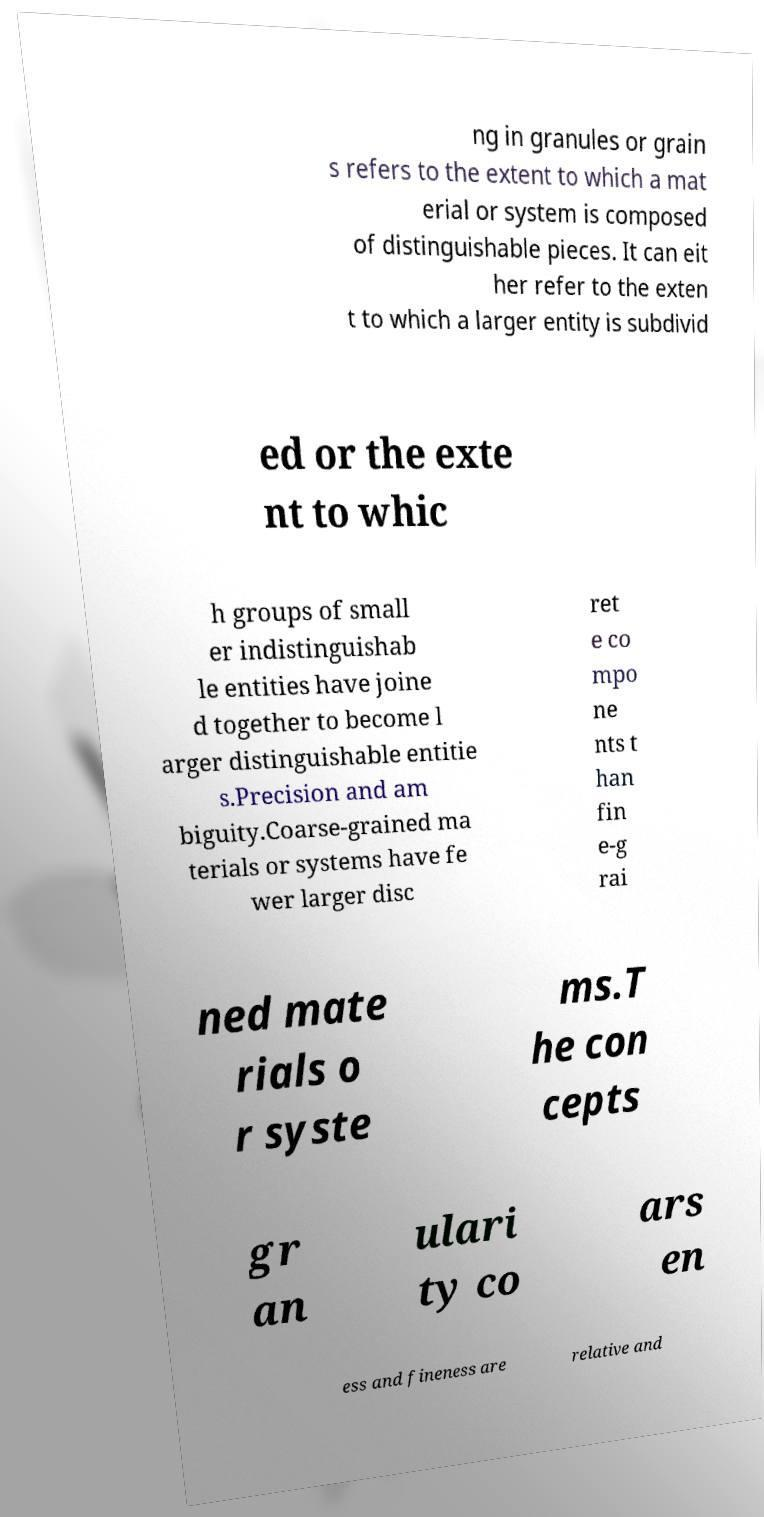Please identify and transcribe the text found in this image. ng in granules or grain s refers to the extent to which a mat erial or system is composed of distinguishable pieces. It can eit her refer to the exten t to which a larger entity is subdivid ed or the exte nt to whic h groups of small er indistinguishab le entities have joine d together to become l arger distinguishable entitie s.Precision and am biguity.Coarse-grained ma terials or systems have fe wer larger disc ret e co mpo ne nts t han fin e-g rai ned mate rials o r syste ms.T he con cepts gr an ulari ty co ars en ess and fineness are relative and 